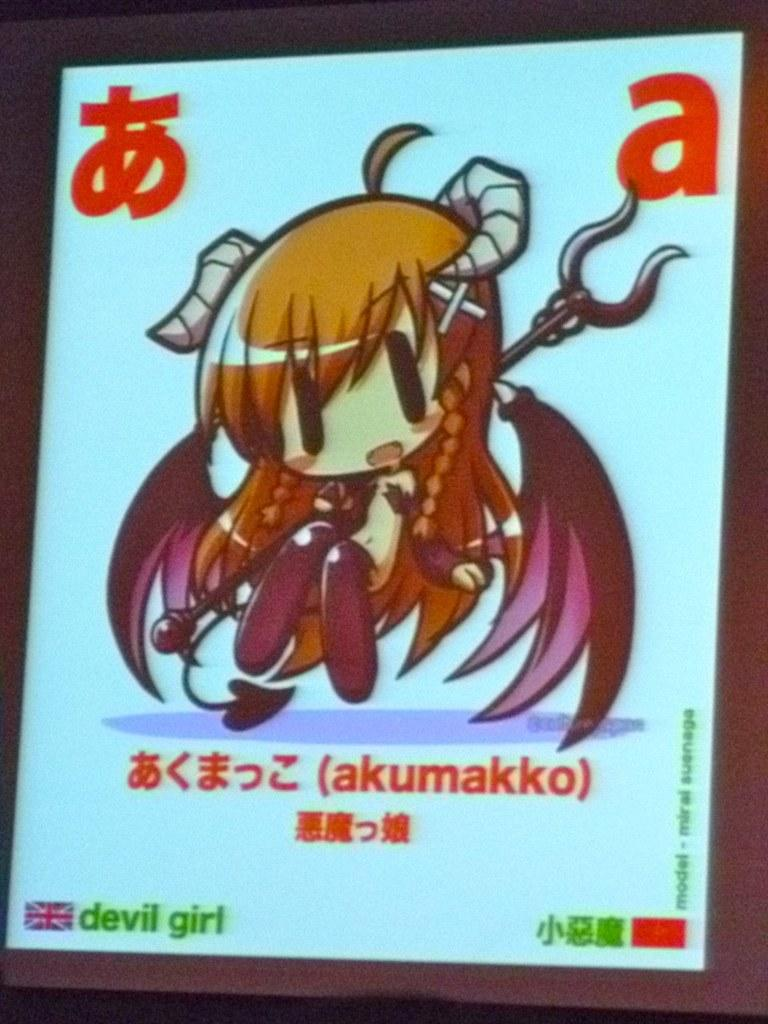<image>
Write a terse but informative summary of the picture. Screen that shows an anime girl and the word "akumakko". 